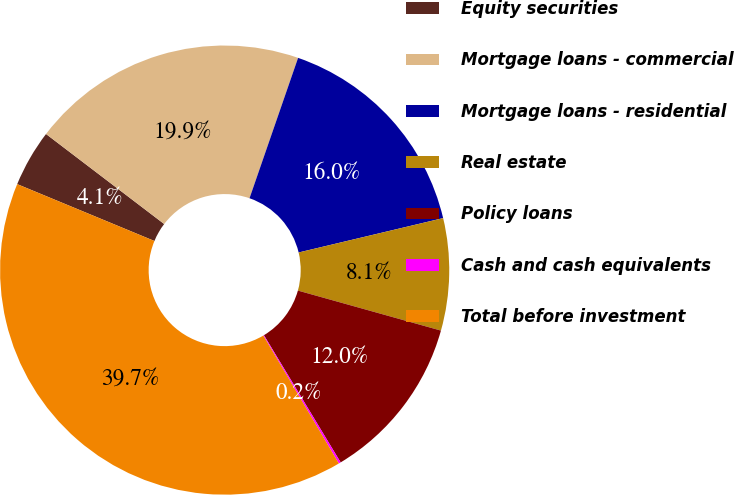Convert chart. <chart><loc_0><loc_0><loc_500><loc_500><pie_chart><fcel>Equity securities<fcel>Mortgage loans - commercial<fcel>Mortgage loans - residential<fcel>Real estate<fcel>Policy loans<fcel>Cash and cash equivalents<fcel>Total before investment<nl><fcel>4.11%<fcel>19.94%<fcel>15.98%<fcel>8.06%<fcel>12.02%<fcel>0.15%<fcel>39.74%<nl></chart> 